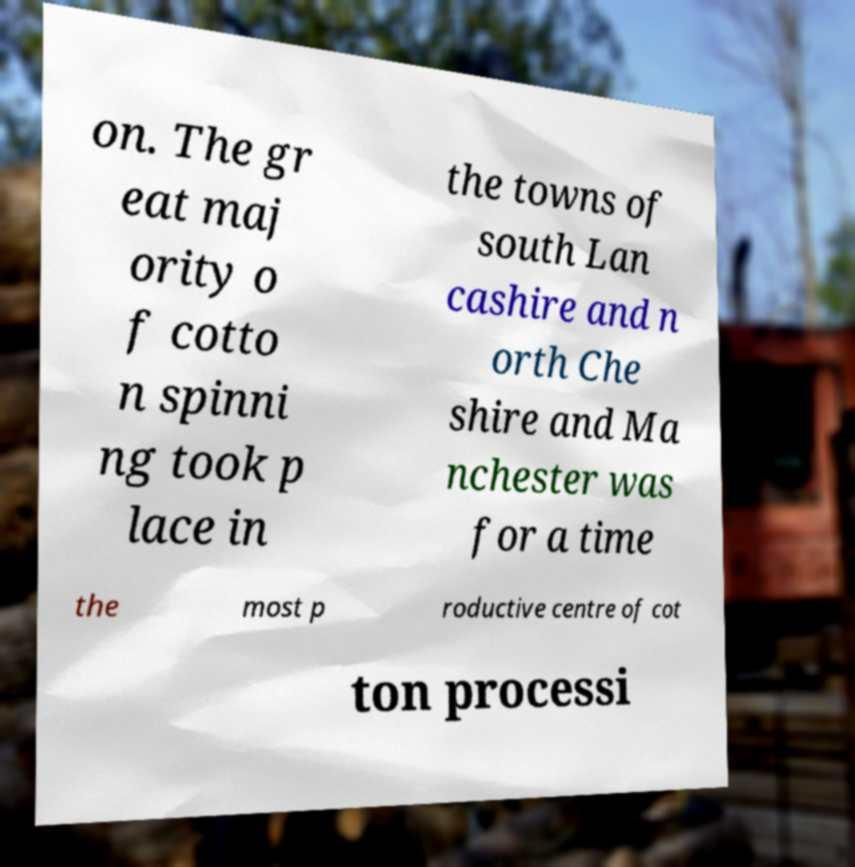Could you extract and type out the text from this image? on. The gr eat maj ority o f cotto n spinni ng took p lace in the towns of south Lan cashire and n orth Che shire and Ma nchester was for a time the most p roductive centre of cot ton processi 